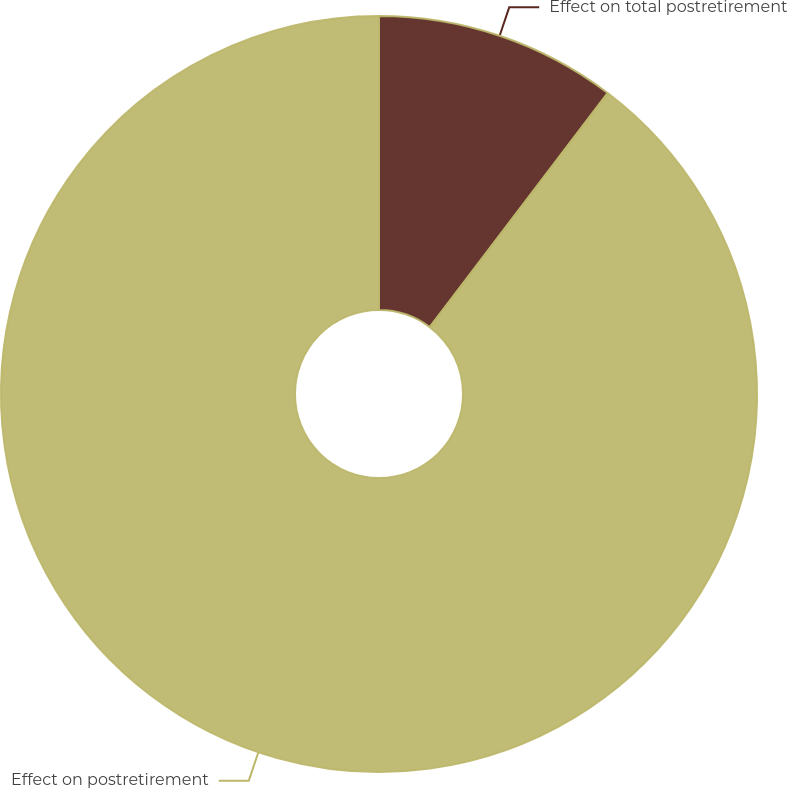<chart> <loc_0><loc_0><loc_500><loc_500><pie_chart><fcel>Effect on total postretirement<fcel>Effect on postretirement<nl><fcel>10.34%<fcel>89.66%<nl></chart> 